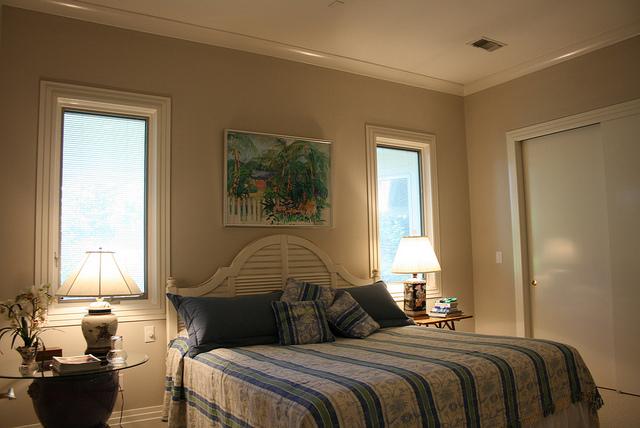What color are the pillows on the bed?
Answer briefly. Blue. What color is the comforter?
Answer briefly. Blue and white. How many windows are in this room?
Keep it brief. 2. Is the bedding plaid or striped?
Be succinct. Striped. How many decorative pillows are on the bed?
Short answer required. 3. Is there a TV in this room?
Quick response, please. No. Is the light on?
Quick response, please. Yes. 